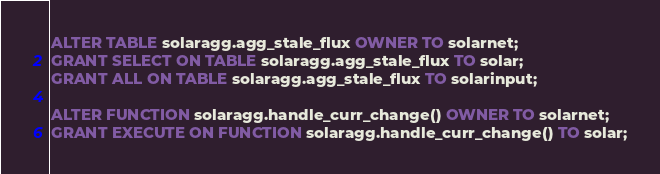<code> <loc_0><loc_0><loc_500><loc_500><_SQL_>ALTER TABLE solaragg.agg_stale_flux OWNER TO solarnet;
GRANT SELECT ON TABLE solaragg.agg_stale_flux TO solar;
GRANT ALL ON TABLE solaragg.agg_stale_flux TO solarinput;

ALTER FUNCTION solaragg.handle_curr_change() OWNER TO solarnet;
GRANT EXECUTE ON FUNCTION solaragg.handle_curr_change() TO solar;
</code> 